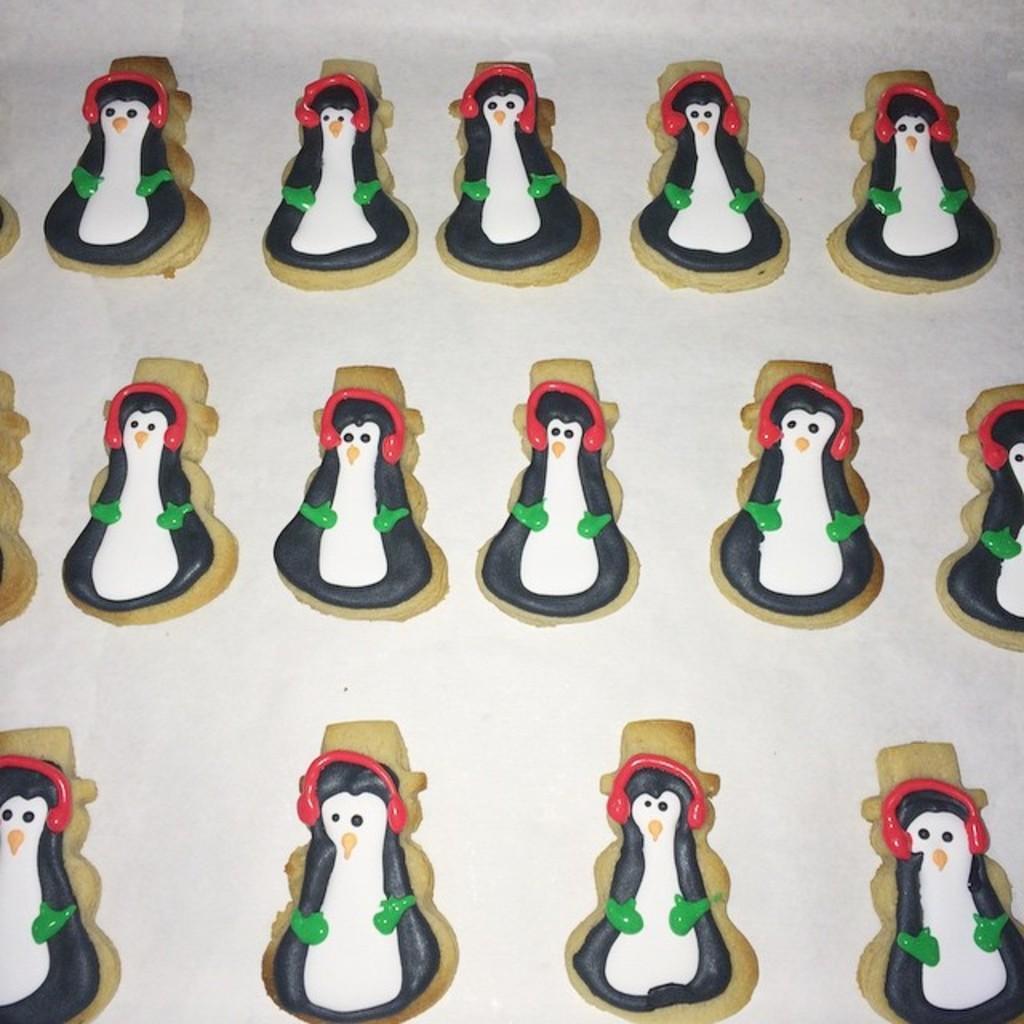In one or two sentences, can you explain what this image depicts? In this image I can see few toys made with clay and these are placed on a white surface. 